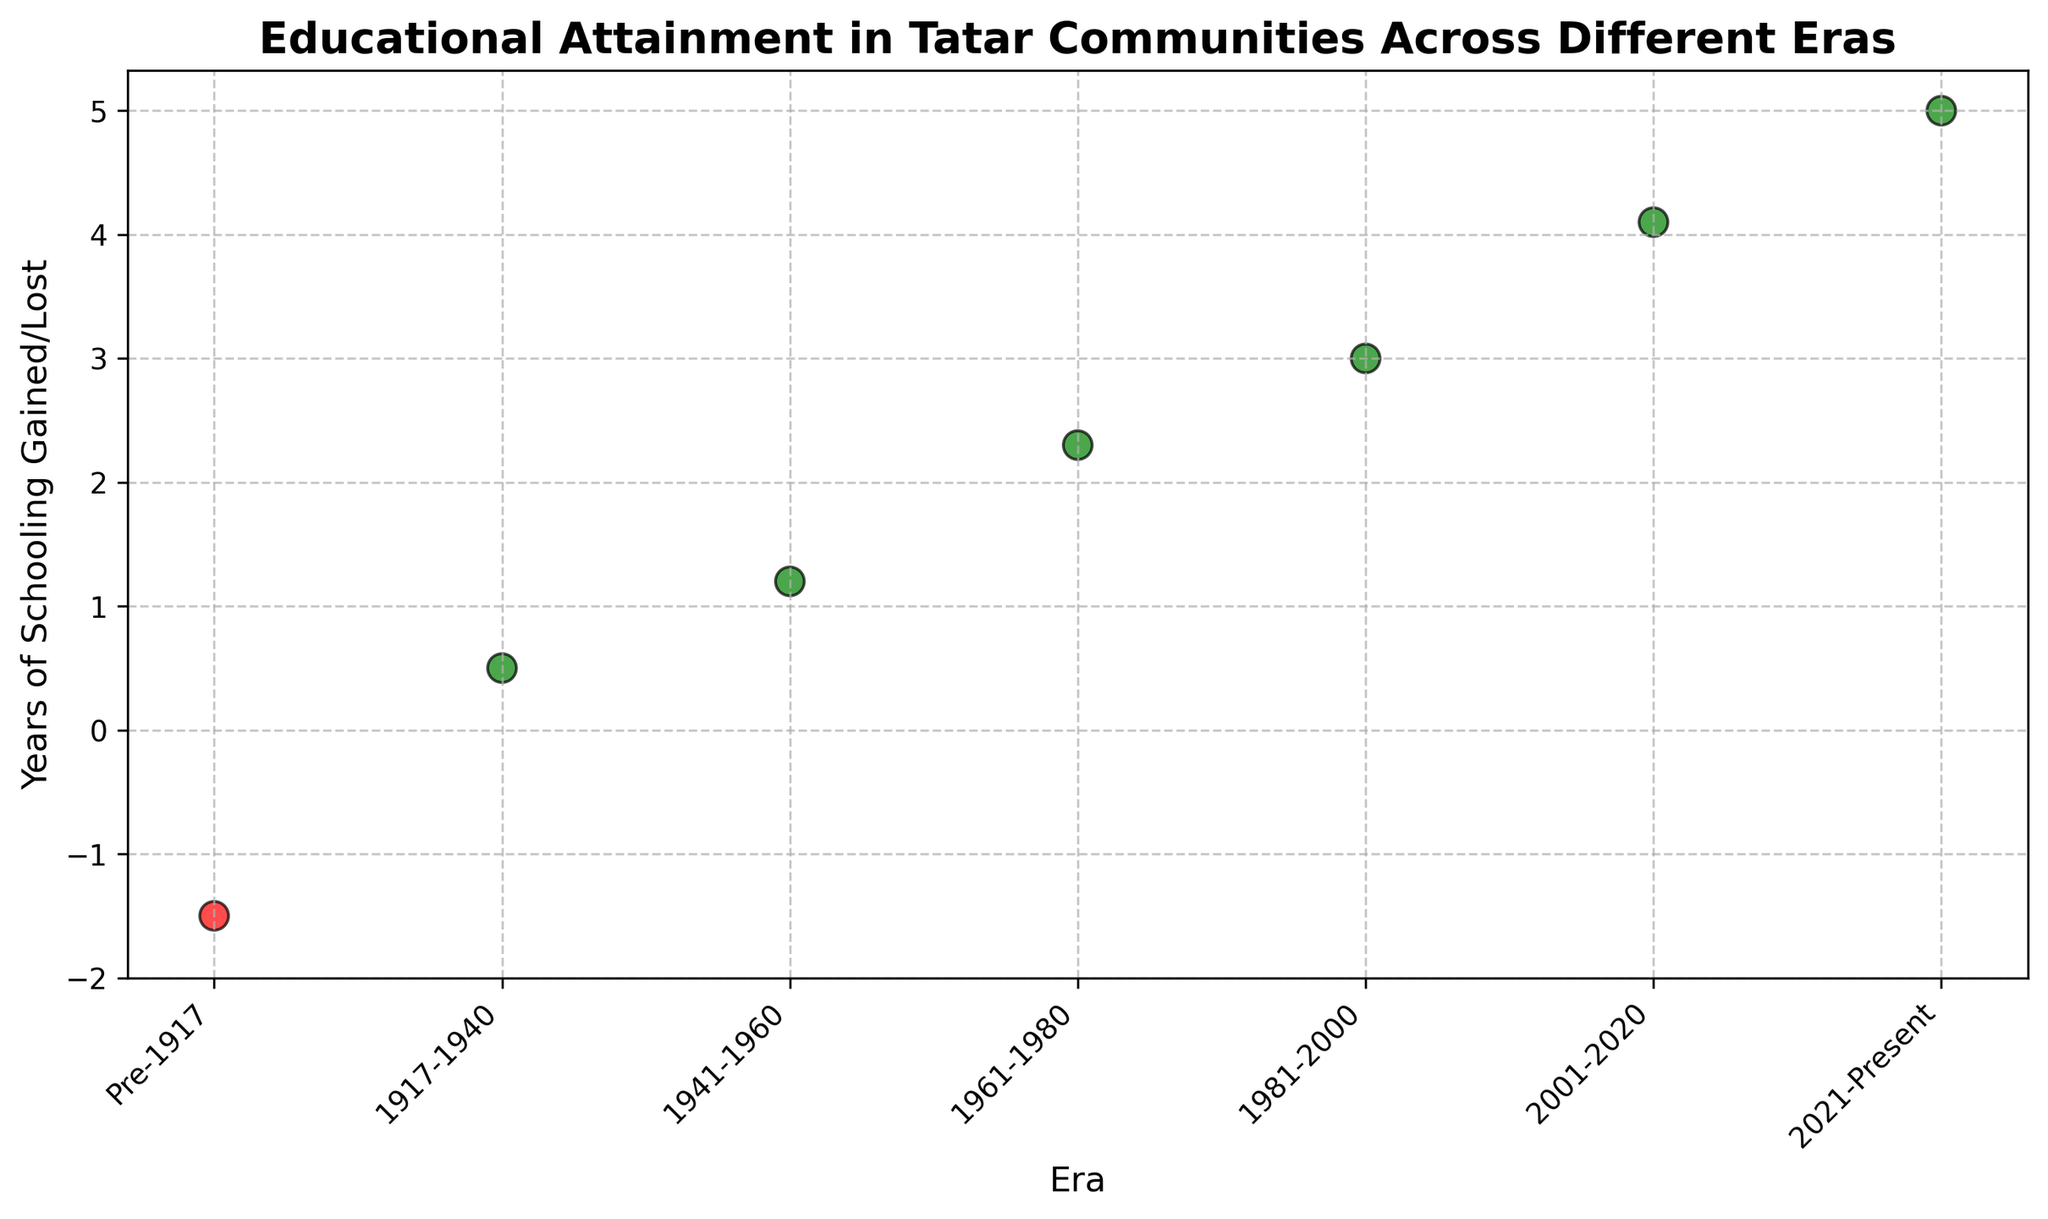When did the Tatar communities experience a decrease in educational attainment? Look at the years where the data points are negative. The only negative value is in the "Pre-1917" era.
Answer: Pre-1917 Between which eras did the educational attainment see the most significant increase? Compare the changes between each consecutive era. The most significant jump is between "2001-2020" and "2021-Present" with a 0.9 increase (from 4.1 to 5.0).
Answer: 2001-2020 to 2021-Present What is the total increase in years of schooling from "Pre-1917" to "2021-Present"? To find the total increase, subtract the earliest value from the latest value: 5.0 - (-1.5) = 6.5.
Answer: 6.5 In how many eras did the Tatar communities experience gains in years of schooling? Count the number of positive values in the data. The positive values are from 1917-1940 onwards, totaling 6 eras.
Answer: 6 Which era directly followed a negative educational attainment? The era with negative educational attainment is "Pre-1917". The era that directly follows is "1917-1940".
Answer: 1917-1940 How does the educational attainment in "1961-1980" compare to that in "1981-2000"? Compare the values for these eras: 2.3 for "1961-1980" and 3.0 for "1981-2000". "1981-2000" is higher.
Answer: 1981-2000 is higher What is the average increase in years of schooling across all the eras with positive values? Use only the positive values: 0.5, 1.2, 2.3, 3.0, 4.1, and 5.0. Calculate the average: (0.5 + 1.2 + 2.3 + 3.0 + 4.1 + 5.0) / 6 ≈ 2.68.
Answer: 2.68 Which era marks the beginning of a more substantial upward trend in educational attainment? Observe the consistent upward trend and note where it begins. The increase starts becoming more consistent and substantial from "1961-1980".
Answer: 1961-1980 